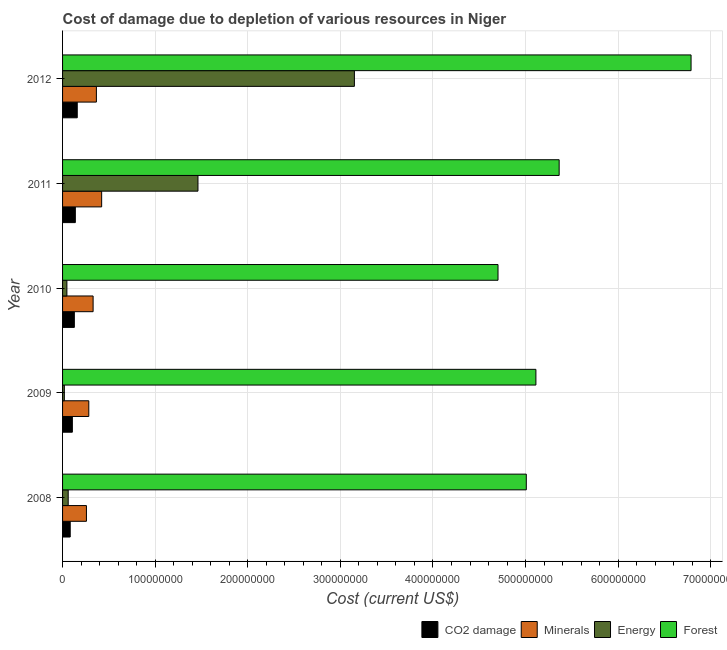How many different coloured bars are there?
Provide a succinct answer. 4. Are the number of bars per tick equal to the number of legend labels?
Your answer should be very brief. Yes. How many bars are there on the 2nd tick from the top?
Your answer should be very brief. 4. How many bars are there on the 5th tick from the bottom?
Your answer should be very brief. 4. In how many cases, is the number of bars for a given year not equal to the number of legend labels?
Provide a succinct answer. 0. What is the cost of damage due to depletion of forests in 2008?
Ensure brevity in your answer.  5.01e+08. Across all years, what is the maximum cost of damage due to depletion of coal?
Make the answer very short. 1.59e+07. Across all years, what is the minimum cost of damage due to depletion of minerals?
Give a very brief answer. 2.58e+07. In which year was the cost of damage due to depletion of energy minimum?
Your answer should be very brief. 2009. What is the total cost of damage due to depletion of energy in the graph?
Ensure brevity in your answer.  4.74e+08. What is the difference between the cost of damage due to depletion of coal in 2009 and that in 2012?
Provide a succinct answer. -5.28e+06. What is the difference between the cost of damage due to depletion of coal in 2011 and the cost of damage due to depletion of forests in 2009?
Give a very brief answer. -4.97e+08. What is the average cost of damage due to depletion of energy per year?
Your answer should be compact. 9.48e+07. In the year 2012, what is the difference between the cost of damage due to depletion of energy and cost of damage due to depletion of forests?
Keep it short and to the point. -3.64e+08. In how many years, is the cost of damage due to depletion of forests greater than 380000000 US$?
Your answer should be very brief. 5. What is the ratio of the cost of damage due to depletion of coal in 2008 to that in 2012?
Offer a terse response. 0.52. Is the difference between the cost of damage due to depletion of coal in 2008 and 2011 greater than the difference between the cost of damage due to depletion of forests in 2008 and 2011?
Ensure brevity in your answer.  Yes. What is the difference between the highest and the second highest cost of damage due to depletion of energy?
Offer a terse response. 1.69e+08. What is the difference between the highest and the lowest cost of damage due to depletion of coal?
Offer a very short reply. 7.59e+06. In how many years, is the cost of damage due to depletion of forests greater than the average cost of damage due to depletion of forests taken over all years?
Make the answer very short. 1. Is the sum of the cost of damage due to depletion of forests in 2009 and 2012 greater than the maximum cost of damage due to depletion of energy across all years?
Offer a terse response. Yes. What does the 3rd bar from the top in 2012 represents?
Provide a succinct answer. Minerals. What does the 4th bar from the bottom in 2009 represents?
Provide a short and direct response. Forest. Is it the case that in every year, the sum of the cost of damage due to depletion of coal and cost of damage due to depletion of minerals is greater than the cost of damage due to depletion of energy?
Provide a short and direct response. No. How many bars are there?
Keep it short and to the point. 20. Are all the bars in the graph horizontal?
Your answer should be very brief. Yes. Are the values on the major ticks of X-axis written in scientific E-notation?
Provide a succinct answer. No. Where does the legend appear in the graph?
Offer a very short reply. Bottom right. How many legend labels are there?
Your answer should be very brief. 4. How are the legend labels stacked?
Provide a short and direct response. Horizontal. What is the title of the graph?
Make the answer very short. Cost of damage due to depletion of various resources in Niger . What is the label or title of the X-axis?
Ensure brevity in your answer.  Cost (current US$). What is the Cost (current US$) of CO2 damage in 2008?
Offer a terse response. 8.27e+06. What is the Cost (current US$) of Minerals in 2008?
Provide a succinct answer. 2.58e+07. What is the Cost (current US$) of Energy in 2008?
Keep it short and to the point. 6.09e+06. What is the Cost (current US$) in Forest in 2008?
Provide a short and direct response. 5.01e+08. What is the Cost (current US$) in CO2 damage in 2009?
Keep it short and to the point. 1.06e+07. What is the Cost (current US$) in Minerals in 2009?
Your response must be concise. 2.83e+07. What is the Cost (current US$) of Energy in 2009?
Your answer should be compact. 1.92e+06. What is the Cost (current US$) of Forest in 2009?
Provide a short and direct response. 5.11e+08. What is the Cost (current US$) of CO2 damage in 2010?
Your answer should be compact. 1.27e+07. What is the Cost (current US$) of Minerals in 2010?
Give a very brief answer. 3.30e+07. What is the Cost (current US$) of Energy in 2010?
Your answer should be very brief. 4.68e+06. What is the Cost (current US$) of Forest in 2010?
Your answer should be very brief. 4.70e+08. What is the Cost (current US$) in CO2 damage in 2011?
Provide a short and direct response. 1.38e+07. What is the Cost (current US$) in Minerals in 2011?
Ensure brevity in your answer.  4.22e+07. What is the Cost (current US$) of Energy in 2011?
Ensure brevity in your answer.  1.46e+08. What is the Cost (current US$) in Forest in 2011?
Ensure brevity in your answer.  5.36e+08. What is the Cost (current US$) in CO2 damage in 2012?
Ensure brevity in your answer.  1.59e+07. What is the Cost (current US$) of Minerals in 2012?
Offer a terse response. 3.65e+07. What is the Cost (current US$) of Energy in 2012?
Provide a succinct answer. 3.15e+08. What is the Cost (current US$) in Forest in 2012?
Ensure brevity in your answer.  6.79e+08. Across all years, what is the maximum Cost (current US$) in CO2 damage?
Provide a succinct answer. 1.59e+07. Across all years, what is the maximum Cost (current US$) in Minerals?
Make the answer very short. 4.22e+07. Across all years, what is the maximum Cost (current US$) of Energy?
Provide a succinct answer. 3.15e+08. Across all years, what is the maximum Cost (current US$) in Forest?
Provide a short and direct response. 6.79e+08. Across all years, what is the minimum Cost (current US$) of CO2 damage?
Your response must be concise. 8.27e+06. Across all years, what is the minimum Cost (current US$) in Minerals?
Provide a short and direct response. 2.58e+07. Across all years, what is the minimum Cost (current US$) of Energy?
Your answer should be very brief. 1.92e+06. Across all years, what is the minimum Cost (current US$) in Forest?
Your response must be concise. 4.70e+08. What is the total Cost (current US$) of CO2 damage in the graph?
Offer a terse response. 6.12e+07. What is the total Cost (current US$) of Minerals in the graph?
Offer a very short reply. 1.66e+08. What is the total Cost (current US$) in Energy in the graph?
Ensure brevity in your answer.  4.74e+08. What is the total Cost (current US$) in Forest in the graph?
Provide a succinct answer. 2.70e+09. What is the difference between the Cost (current US$) in CO2 damage in 2008 and that in 2009?
Your response must be concise. -2.31e+06. What is the difference between the Cost (current US$) in Minerals in 2008 and that in 2009?
Provide a short and direct response. -2.54e+06. What is the difference between the Cost (current US$) of Energy in 2008 and that in 2009?
Keep it short and to the point. 4.17e+06. What is the difference between the Cost (current US$) of Forest in 2008 and that in 2009?
Offer a very short reply. -1.04e+07. What is the difference between the Cost (current US$) in CO2 damage in 2008 and that in 2010?
Give a very brief answer. -4.44e+06. What is the difference between the Cost (current US$) in Minerals in 2008 and that in 2010?
Keep it short and to the point. -7.20e+06. What is the difference between the Cost (current US$) in Energy in 2008 and that in 2010?
Ensure brevity in your answer.  1.41e+06. What is the difference between the Cost (current US$) of Forest in 2008 and that in 2010?
Provide a short and direct response. 3.05e+07. What is the difference between the Cost (current US$) of CO2 damage in 2008 and that in 2011?
Your answer should be compact. -5.52e+06. What is the difference between the Cost (current US$) of Minerals in 2008 and that in 2011?
Your answer should be compact. -1.64e+07. What is the difference between the Cost (current US$) in Energy in 2008 and that in 2011?
Provide a short and direct response. -1.40e+08. What is the difference between the Cost (current US$) of Forest in 2008 and that in 2011?
Your answer should be compact. -3.55e+07. What is the difference between the Cost (current US$) of CO2 damage in 2008 and that in 2012?
Provide a short and direct response. -7.59e+06. What is the difference between the Cost (current US$) of Minerals in 2008 and that in 2012?
Ensure brevity in your answer.  -1.07e+07. What is the difference between the Cost (current US$) of Energy in 2008 and that in 2012?
Your answer should be compact. -3.09e+08. What is the difference between the Cost (current US$) in Forest in 2008 and that in 2012?
Your answer should be compact. -1.78e+08. What is the difference between the Cost (current US$) of CO2 damage in 2009 and that in 2010?
Provide a short and direct response. -2.14e+06. What is the difference between the Cost (current US$) of Minerals in 2009 and that in 2010?
Your response must be concise. -4.65e+06. What is the difference between the Cost (current US$) of Energy in 2009 and that in 2010?
Provide a succinct answer. -2.76e+06. What is the difference between the Cost (current US$) of Forest in 2009 and that in 2010?
Make the answer very short. 4.09e+07. What is the difference between the Cost (current US$) in CO2 damage in 2009 and that in 2011?
Give a very brief answer. -3.21e+06. What is the difference between the Cost (current US$) of Minerals in 2009 and that in 2011?
Your answer should be compact. -1.39e+07. What is the difference between the Cost (current US$) of Energy in 2009 and that in 2011?
Your answer should be compact. -1.44e+08. What is the difference between the Cost (current US$) of Forest in 2009 and that in 2011?
Your answer should be compact. -2.51e+07. What is the difference between the Cost (current US$) of CO2 damage in 2009 and that in 2012?
Give a very brief answer. -5.28e+06. What is the difference between the Cost (current US$) of Minerals in 2009 and that in 2012?
Ensure brevity in your answer.  -8.20e+06. What is the difference between the Cost (current US$) in Energy in 2009 and that in 2012?
Your response must be concise. -3.13e+08. What is the difference between the Cost (current US$) of Forest in 2009 and that in 2012?
Give a very brief answer. -1.68e+08. What is the difference between the Cost (current US$) of CO2 damage in 2010 and that in 2011?
Offer a very short reply. -1.07e+06. What is the difference between the Cost (current US$) of Minerals in 2010 and that in 2011?
Provide a succinct answer. -9.24e+06. What is the difference between the Cost (current US$) of Energy in 2010 and that in 2011?
Your answer should be very brief. -1.42e+08. What is the difference between the Cost (current US$) of Forest in 2010 and that in 2011?
Make the answer very short. -6.60e+07. What is the difference between the Cost (current US$) of CO2 damage in 2010 and that in 2012?
Provide a short and direct response. -3.15e+06. What is the difference between the Cost (current US$) in Minerals in 2010 and that in 2012?
Offer a very short reply. -3.54e+06. What is the difference between the Cost (current US$) of Energy in 2010 and that in 2012?
Provide a short and direct response. -3.10e+08. What is the difference between the Cost (current US$) of Forest in 2010 and that in 2012?
Provide a short and direct response. -2.08e+08. What is the difference between the Cost (current US$) in CO2 damage in 2011 and that in 2012?
Provide a succinct answer. -2.07e+06. What is the difference between the Cost (current US$) of Minerals in 2011 and that in 2012?
Keep it short and to the point. 5.69e+06. What is the difference between the Cost (current US$) of Energy in 2011 and that in 2012?
Offer a terse response. -1.69e+08. What is the difference between the Cost (current US$) of Forest in 2011 and that in 2012?
Your answer should be compact. -1.42e+08. What is the difference between the Cost (current US$) of CO2 damage in 2008 and the Cost (current US$) of Minerals in 2009?
Your answer should be very brief. -2.01e+07. What is the difference between the Cost (current US$) in CO2 damage in 2008 and the Cost (current US$) in Energy in 2009?
Offer a very short reply. 6.35e+06. What is the difference between the Cost (current US$) in CO2 damage in 2008 and the Cost (current US$) in Forest in 2009?
Make the answer very short. -5.03e+08. What is the difference between the Cost (current US$) of Minerals in 2008 and the Cost (current US$) of Energy in 2009?
Keep it short and to the point. 2.39e+07. What is the difference between the Cost (current US$) of Minerals in 2008 and the Cost (current US$) of Forest in 2009?
Make the answer very short. -4.85e+08. What is the difference between the Cost (current US$) in Energy in 2008 and the Cost (current US$) in Forest in 2009?
Provide a short and direct response. -5.05e+08. What is the difference between the Cost (current US$) of CO2 damage in 2008 and the Cost (current US$) of Minerals in 2010?
Provide a succinct answer. -2.47e+07. What is the difference between the Cost (current US$) in CO2 damage in 2008 and the Cost (current US$) in Energy in 2010?
Keep it short and to the point. 3.60e+06. What is the difference between the Cost (current US$) in CO2 damage in 2008 and the Cost (current US$) in Forest in 2010?
Make the answer very short. -4.62e+08. What is the difference between the Cost (current US$) of Minerals in 2008 and the Cost (current US$) of Energy in 2010?
Keep it short and to the point. 2.11e+07. What is the difference between the Cost (current US$) in Minerals in 2008 and the Cost (current US$) in Forest in 2010?
Provide a short and direct response. -4.44e+08. What is the difference between the Cost (current US$) in Energy in 2008 and the Cost (current US$) in Forest in 2010?
Give a very brief answer. -4.64e+08. What is the difference between the Cost (current US$) of CO2 damage in 2008 and the Cost (current US$) of Minerals in 2011?
Give a very brief answer. -3.39e+07. What is the difference between the Cost (current US$) in CO2 damage in 2008 and the Cost (current US$) in Energy in 2011?
Your response must be concise. -1.38e+08. What is the difference between the Cost (current US$) in CO2 damage in 2008 and the Cost (current US$) in Forest in 2011?
Offer a very short reply. -5.28e+08. What is the difference between the Cost (current US$) in Minerals in 2008 and the Cost (current US$) in Energy in 2011?
Your response must be concise. -1.20e+08. What is the difference between the Cost (current US$) in Minerals in 2008 and the Cost (current US$) in Forest in 2011?
Make the answer very short. -5.10e+08. What is the difference between the Cost (current US$) in Energy in 2008 and the Cost (current US$) in Forest in 2011?
Ensure brevity in your answer.  -5.30e+08. What is the difference between the Cost (current US$) of CO2 damage in 2008 and the Cost (current US$) of Minerals in 2012?
Your answer should be compact. -2.83e+07. What is the difference between the Cost (current US$) in CO2 damage in 2008 and the Cost (current US$) in Energy in 2012?
Your response must be concise. -3.07e+08. What is the difference between the Cost (current US$) of CO2 damage in 2008 and the Cost (current US$) of Forest in 2012?
Ensure brevity in your answer.  -6.70e+08. What is the difference between the Cost (current US$) of Minerals in 2008 and the Cost (current US$) of Energy in 2012?
Your response must be concise. -2.89e+08. What is the difference between the Cost (current US$) in Minerals in 2008 and the Cost (current US$) in Forest in 2012?
Provide a short and direct response. -6.53e+08. What is the difference between the Cost (current US$) of Energy in 2008 and the Cost (current US$) of Forest in 2012?
Offer a very short reply. -6.73e+08. What is the difference between the Cost (current US$) of CO2 damage in 2009 and the Cost (current US$) of Minerals in 2010?
Your answer should be very brief. -2.24e+07. What is the difference between the Cost (current US$) in CO2 damage in 2009 and the Cost (current US$) in Energy in 2010?
Provide a succinct answer. 5.90e+06. What is the difference between the Cost (current US$) of CO2 damage in 2009 and the Cost (current US$) of Forest in 2010?
Ensure brevity in your answer.  -4.60e+08. What is the difference between the Cost (current US$) in Minerals in 2009 and the Cost (current US$) in Energy in 2010?
Keep it short and to the point. 2.37e+07. What is the difference between the Cost (current US$) of Minerals in 2009 and the Cost (current US$) of Forest in 2010?
Offer a terse response. -4.42e+08. What is the difference between the Cost (current US$) in Energy in 2009 and the Cost (current US$) in Forest in 2010?
Offer a very short reply. -4.68e+08. What is the difference between the Cost (current US$) of CO2 damage in 2009 and the Cost (current US$) of Minerals in 2011?
Provide a succinct answer. -3.16e+07. What is the difference between the Cost (current US$) of CO2 damage in 2009 and the Cost (current US$) of Energy in 2011?
Your answer should be very brief. -1.36e+08. What is the difference between the Cost (current US$) in CO2 damage in 2009 and the Cost (current US$) in Forest in 2011?
Your answer should be compact. -5.26e+08. What is the difference between the Cost (current US$) of Minerals in 2009 and the Cost (current US$) of Energy in 2011?
Ensure brevity in your answer.  -1.18e+08. What is the difference between the Cost (current US$) in Minerals in 2009 and the Cost (current US$) in Forest in 2011?
Give a very brief answer. -5.08e+08. What is the difference between the Cost (current US$) in Energy in 2009 and the Cost (current US$) in Forest in 2011?
Keep it short and to the point. -5.34e+08. What is the difference between the Cost (current US$) in CO2 damage in 2009 and the Cost (current US$) in Minerals in 2012?
Your answer should be very brief. -2.59e+07. What is the difference between the Cost (current US$) of CO2 damage in 2009 and the Cost (current US$) of Energy in 2012?
Offer a terse response. -3.05e+08. What is the difference between the Cost (current US$) in CO2 damage in 2009 and the Cost (current US$) in Forest in 2012?
Give a very brief answer. -6.68e+08. What is the difference between the Cost (current US$) of Minerals in 2009 and the Cost (current US$) of Energy in 2012?
Your answer should be very brief. -2.87e+08. What is the difference between the Cost (current US$) of Minerals in 2009 and the Cost (current US$) of Forest in 2012?
Provide a succinct answer. -6.50e+08. What is the difference between the Cost (current US$) in Energy in 2009 and the Cost (current US$) in Forest in 2012?
Offer a very short reply. -6.77e+08. What is the difference between the Cost (current US$) of CO2 damage in 2010 and the Cost (current US$) of Minerals in 2011?
Make the answer very short. -2.95e+07. What is the difference between the Cost (current US$) of CO2 damage in 2010 and the Cost (current US$) of Energy in 2011?
Your answer should be compact. -1.34e+08. What is the difference between the Cost (current US$) of CO2 damage in 2010 and the Cost (current US$) of Forest in 2011?
Offer a terse response. -5.24e+08. What is the difference between the Cost (current US$) in Minerals in 2010 and the Cost (current US$) in Energy in 2011?
Your answer should be very brief. -1.13e+08. What is the difference between the Cost (current US$) of Minerals in 2010 and the Cost (current US$) of Forest in 2011?
Keep it short and to the point. -5.03e+08. What is the difference between the Cost (current US$) of Energy in 2010 and the Cost (current US$) of Forest in 2011?
Provide a short and direct response. -5.32e+08. What is the difference between the Cost (current US$) of CO2 damage in 2010 and the Cost (current US$) of Minerals in 2012?
Provide a short and direct response. -2.38e+07. What is the difference between the Cost (current US$) in CO2 damage in 2010 and the Cost (current US$) in Energy in 2012?
Ensure brevity in your answer.  -3.02e+08. What is the difference between the Cost (current US$) in CO2 damage in 2010 and the Cost (current US$) in Forest in 2012?
Offer a terse response. -6.66e+08. What is the difference between the Cost (current US$) of Minerals in 2010 and the Cost (current US$) of Energy in 2012?
Make the answer very short. -2.82e+08. What is the difference between the Cost (current US$) in Minerals in 2010 and the Cost (current US$) in Forest in 2012?
Your answer should be compact. -6.46e+08. What is the difference between the Cost (current US$) in Energy in 2010 and the Cost (current US$) in Forest in 2012?
Offer a terse response. -6.74e+08. What is the difference between the Cost (current US$) of CO2 damage in 2011 and the Cost (current US$) of Minerals in 2012?
Ensure brevity in your answer.  -2.27e+07. What is the difference between the Cost (current US$) in CO2 damage in 2011 and the Cost (current US$) in Energy in 2012?
Your answer should be very brief. -3.01e+08. What is the difference between the Cost (current US$) in CO2 damage in 2011 and the Cost (current US$) in Forest in 2012?
Your response must be concise. -6.65e+08. What is the difference between the Cost (current US$) in Minerals in 2011 and the Cost (current US$) in Energy in 2012?
Your answer should be very brief. -2.73e+08. What is the difference between the Cost (current US$) of Minerals in 2011 and the Cost (current US$) of Forest in 2012?
Your response must be concise. -6.36e+08. What is the difference between the Cost (current US$) in Energy in 2011 and the Cost (current US$) in Forest in 2012?
Provide a short and direct response. -5.32e+08. What is the average Cost (current US$) of CO2 damage per year?
Your answer should be very brief. 1.22e+07. What is the average Cost (current US$) in Minerals per year?
Provide a short and direct response. 3.32e+07. What is the average Cost (current US$) of Energy per year?
Make the answer very short. 9.48e+07. What is the average Cost (current US$) in Forest per year?
Give a very brief answer. 5.39e+08. In the year 2008, what is the difference between the Cost (current US$) of CO2 damage and Cost (current US$) of Minerals?
Provide a short and direct response. -1.75e+07. In the year 2008, what is the difference between the Cost (current US$) in CO2 damage and Cost (current US$) in Energy?
Make the answer very short. 2.19e+06. In the year 2008, what is the difference between the Cost (current US$) in CO2 damage and Cost (current US$) in Forest?
Make the answer very short. -4.93e+08. In the year 2008, what is the difference between the Cost (current US$) in Minerals and Cost (current US$) in Energy?
Your answer should be very brief. 1.97e+07. In the year 2008, what is the difference between the Cost (current US$) of Minerals and Cost (current US$) of Forest?
Keep it short and to the point. -4.75e+08. In the year 2008, what is the difference between the Cost (current US$) of Energy and Cost (current US$) of Forest?
Make the answer very short. -4.95e+08. In the year 2009, what is the difference between the Cost (current US$) in CO2 damage and Cost (current US$) in Minerals?
Offer a terse response. -1.77e+07. In the year 2009, what is the difference between the Cost (current US$) of CO2 damage and Cost (current US$) of Energy?
Ensure brevity in your answer.  8.66e+06. In the year 2009, what is the difference between the Cost (current US$) of CO2 damage and Cost (current US$) of Forest?
Offer a very short reply. -5.01e+08. In the year 2009, what is the difference between the Cost (current US$) in Minerals and Cost (current US$) in Energy?
Provide a succinct answer. 2.64e+07. In the year 2009, what is the difference between the Cost (current US$) in Minerals and Cost (current US$) in Forest?
Provide a short and direct response. -4.83e+08. In the year 2009, what is the difference between the Cost (current US$) of Energy and Cost (current US$) of Forest?
Offer a very short reply. -5.09e+08. In the year 2010, what is the difference between the Cost (current US$) of CO2 damage and Cost (current US$) of Minerals?
Your response must be concise. -2.03e+07. In the year 2010, what is the difference between the Cost (current US$) of CO2 damage and Cost (current US$) of Energy?
Offer a terse response. 8.04e+06. In the year 2010, what is the difference between the Cost (current US$) in CO2 damage and Cost (current US$) in Forest?
Provide a short and direct response. -4.58e+08. In the year 2010, what is the difference between the Cost (current US$) in Minerals and Cost (current US$) in Energy?
Provide a succinct answer. 2.83e+07. In the year 2010, what is the difference between the Cost (current US$) of Minerals and Cost (current US$) of Forest?
Offer a terse response. -4.37e+08. In the year 2010, what is the difference between the Cost (current US$) in Energy and Cost (current US$) in Forest?
Provide a short and direct response. -4.66e+08. In the year 2011, what is the difference between the Cost (current US$) of CO2 damage and Cost (current US$) of Minerals?
Your answer should be very brief. -2.84e+07. In the year 2011, what is the difference between the Cost (current US$) of CO2 damage and Cost (current US$) of Energy?
Provide a short and direct response. -1.32e+08. In the year 2011, what is the difference between the Cost (current US$) of CO2 damage and Cost (current US$) of Forest?
Provide a short and direct response. -5.22e+08. In the year 2011, what is the difference between the Cost (current US$) in Minerals and Cost (current US$) in Energy?
Provide a short and direct response. -1.04e+08. In the year 2011, what is the difference between the Cost (current US$) in Minerals and Cost (current US$) in Forest?
Offer a terse response. -4.94e+08. In the year 2011, what is the difference between the Cost (current US$) of Energy and Cost (current US$) of Forest?
Ensure brevity in your answer.  -3.90e+08. In the year 2012, what is the difference between the Cost (current US$) of CO2 damage and Cost (current US$) of Minerals?
Offer a terse response. -2.07e+07. In the year 2012, what is the difference between the Cost (current US$) in CO2 damage and Cost (current US$) in Energy?
Offer a very short reply. -2.99e+08. In the year 2012, what is the difference between the Cost (current US$) in CO2 damage and Cost (current US$) in Forest?
Keep it short and to the point. -6.63e+08. In the year 2012, what is the difference between the Cost (current US$) in Minerals and Cost (current US$) in Energy?
Offer a terse response. -2.79e+08. In the year 2012, what is the difference between the Cost (current US$) in Minerals and Cost (current US$) in Forest?
Keep it short and to the point. -6.42e+08. In the year 2012, what is the difference between the Cost (current US$) in Energy and Cost (current US$) in Forest?
Make the answer very short. -3.64e+08. What is the ratio of the Cost (current US$) in CO2 damage in 2008 to that in 2009?
Offer a terse response. 0.78. What is the ratio of the Cost (current US$) in Minerals in 2008 to that in 2009?
Your answer should be compact. 0.91. What is the ratio of the Cost (current US$) in Energy in 2008 to that in 2009?
Provide a short and direct response. 3.17. What is the ratio of the Cost (current US$) in Forest in 2008 to that in 2009?
Your answer should be very brief. 0.98. What is the ratio of the Cost (current US$) of CO2 damage in 2008 to that in 2010?
Provide a succinct answer. 0.65. What is the ratio of the Cost (current US$) of Minerals in 2008 to that in 2010?
Ensure brevity in your answer.  0.78. What is the ratio of the Cost (current US$) of Energy in 2008 to that in 2010?
Your answer should be compact. 1.3. What is the ratio of the Cost (current US$) of Forest in 2008 to that in 2010?
Your answer should be compact. 1.06. What is the ratio of the Cost (current US$) of CO2 damage in 2008 to that in 2011?
Keep it short and to the point. 0.6. What is the ratio of the Cost (current US$) of Minerals in 2008 to that in 2011?
Provide a short and direct response. 0.61. What is the ratio of the Cost (current US$) of Energy in 2008 to that in 2011?
Your response must be concise. 0.04. What is the ratio of the Cost (current US$) in Forest in 2008 to that in 2011?
Your response must be concise. 0.93. What is the ratio of the Cost (current US$) in CO2 damage in 2008 to that in 2012?
Your response must be concise. 0.52. What is the ratio of the Cost (current US$) in Minerals in 2008 to that in 2012?
Make the answer very short. 0.71. What is the ratio of the Cost (current US$) of Energy in 2008 to that in 2012?
Your answer should be very brief. 0.02. What is the ratio of the Cost (current US$) of Forest in 2008 to that in 2012?
Your answer should be very brief. 0.74. What is the ratio of the Cost (current US$) of CO2 damage in 2009 to that in 2010?
Give a very brief answer. 0.83. What is the ratio of the Cost (current US$) of Minerals in 2009 to that in 2010?
Keep it short and to the point. 0.86. What is the ratio of the Cost (current US$) in Energy in 2009 to that in 2010?
Make the answer very short. 0.41. What is the ratio of the Cost (current US$) in Forest in 2009 to that in 2010?
Offer a terse response. 1.09. What is the ratio of the Cost (current US$) in CO2 damage in 2009 to that in 2011?
Your answer should be very brief. 0.77. What is the ratio of the Cost (current US$) of Minerals in 2009 to that in 2011?
Offer a very short reply. 0.67. What is the ratio of the Cost (current US$) of Energy in 2009 to that in 2011?
Offer a very short reply. 0.01. What is the ratio of the Cost (current US$) in Forest in 2009 to that in 2011?
Make the answer very short. 0.95. What is the ratio of the Cost (current US$) of CO2 damage in 2009 to that in 2012?
Make the answer very short. 0.67. What is the ratio of the Cost (current US$) in Minerals in 2009 to that in 2012?
Provide a succinct answer. 0.78. What is the ratio of the Cost (current US$) of Energy in 2009 to that in 2012?
Your response must be concise. 0.01. What is the ratio of the Cost (current US$) in Forest in 2009 to that in 2012?
Your answer should be very brief. 0.75. What is the ratio of the Cost (current US$) in CO2 damage in 2010 to that in 2011?
Your answer should be compact. 0.92. What is the ratio of the Cost (current US$) of Minerals in 2010 to that in 2011?
Offer a terse response. 0.78. What is the ratio of the Cost (current US$) of Energy in 2010 to that in 2011?
Offer a terse response. 0.03. What is the ratio of the Cost (current US$) of Forest in 2010 to that in 2011?
Offer a terse response. 0.88. What is the ratio of the Cost (current US$) in CO2 damage in 2010 to that in 2012?
Offer a terse response. 0.8. What is the ratio of the Cost (current US$) of Minerals in 2010 to that in 2012?
Give a very brief answer. 0.9. What is the ratio of the Cost (current US$) of Energy in 2010 to that in 2012?
Offer a very short reply. 0.01. What is the ratio of the Cost (current US$) of Forest in 2010 to that in 2012?
Offer a terse response. 0.69. What is the ratio of the Cost (current US$) in CO2 damage in 2011 to that in 2012?
Ensure brevity in your answer.  0.87. What is the ratio of the Cost (current US$) of Minerals in 2011 to that in 2012?
Provide a succinct answer. 1.16. What is the ratio of the Cost (current US$) in Energy in 2011 to that in 2012?
Offer a terse response. 0.46. What is the ratio of the Cost (current US$) of Forest in 2011 to that in 2012?
Offer a very short reply. 0.79. What is the difference between the highest and the second highest Cost (current US$) of CO2 damage?
Offer a very short reply. 2.07e+06. What is the difference between the highest and the second highest Cost (current US$) of Minerals?
Provide a short and direct response. 5.69e+06. What is the difference between the highest and the second highest Cost (current US$) in Energy?
Provide a short and direct response. 1.69e+08. What is the difference between the highest and the second highest Cost (current US$) of Forest?
Give a very brief answer. 1.42e+08. What is the difference between the highest and the lowest Cost (current US$) of CO2 damage?
Give a very brief answer. 7.59e+06. What is the difference between the highest and the lowest Cost (current US$) in Minerals?
Your answer should be compact. 1.64e+07. What is the difference between the highest and the lowest Cost (current US$) of Energy?
Offer a very short reply. 3.13e+08. What is the difference between the highest and the lowest Cost (current US$) in Forest?
Offer a terse response. 2.08e+08. 